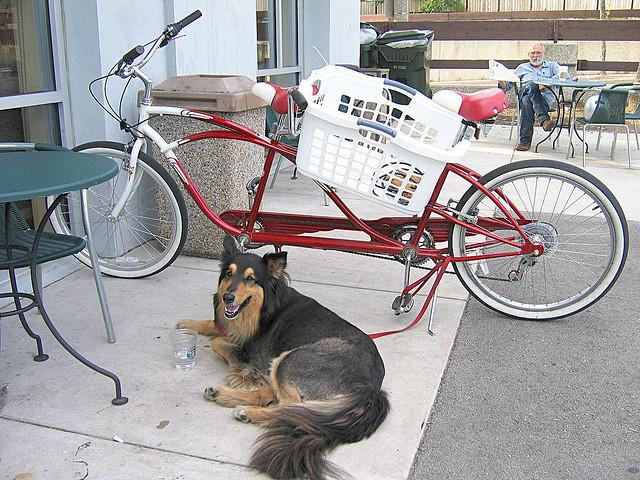What is the bike being used to transport? Please explain your reasoning. hamper. There is a laundry basket on the back of the bike. 